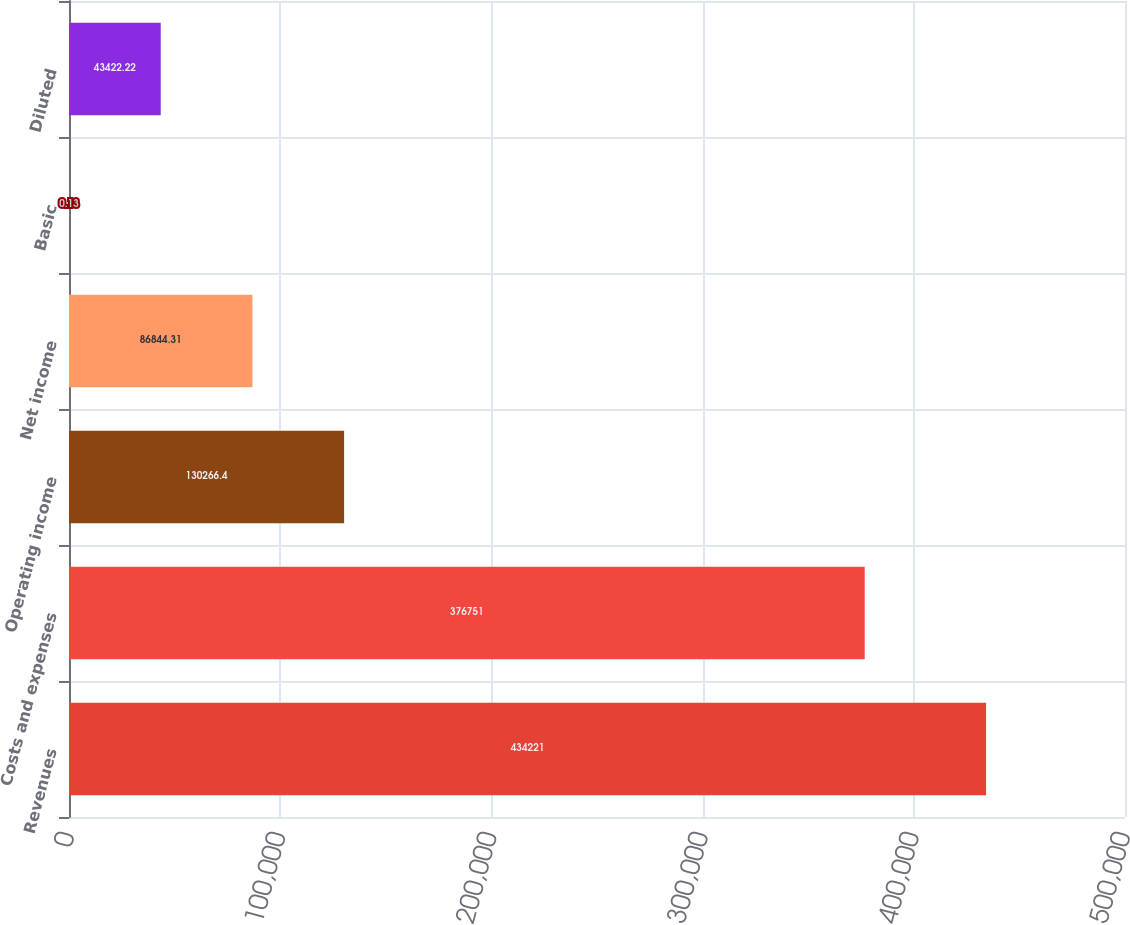Convert chart. <chart><loc_0><loc_0><loc_500><loc_500><bar_chart><fcel>Revenues<fcel>Costs and expenses<fcel>Operating income<fcel>Net income<fcel>Basic<fcel>Diluted<nl><fcel>434221<fcel>376751<fcel>130266<fcel>86844.3<fcel>0.13<fcel>43422.2<nl></chart> 